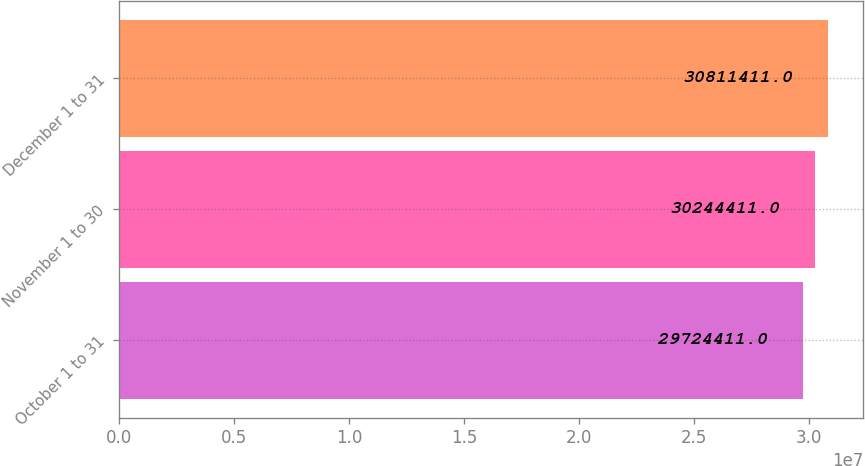Convert chart to OTSL. <chart><loc_0><loc_0><loc_500><loc_500><bar_chart><fcel>October 1 to 31<fcel>November 1 to 30<fcel>December 1 to 31<nl><fcel>2.97244e+07<fcel>3.02444e+07<fcel>3.08114e+07<nl></chart> 